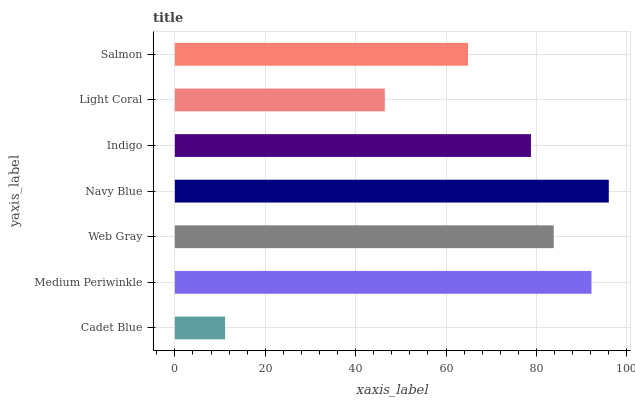Is Cadet Blue the minimum?
Answer yes or no. Yes. Is Navy Blue the maximum?
Answer yes or no. Yes. Is Medium Periwinkle the minimum?
Answer yes or no. No. Is Medium Periwinkle the maximum?
Answer yes or no. No. Is Medium Periwinkle greater than Cadet Blue?
Answer yes or no. Yes. Is Cadet Blue less than Medium Periwinkle?
Answer yes or no. Yes. Is Cadet Blue greater than Medium Periwinkle?
Answer yes or no. No. Is Medium Periwinkle less than Cadet Blue?
Answer yes or no. No. Is Indigo the high median?
Answer yes or no. Yes. Is Indigo the low median?
Answer yes or no. Yes. Is Light Coral the high median?
Answer yes or no. No. Is Web Gray the low median?
Answer yes or no. No. 